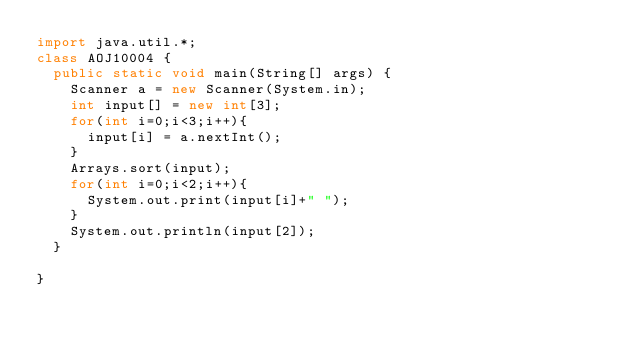<code> <loc_0><loc_0><loc_500><loc_500><_Java_>import java.util.*;
class AOJ10004 {
	public static void main(String[] args) {
		Scanner a = new Scanner(System.in);
		int input[] = new int[3];
		for(int i=0;i<3;i++){
			input[i] = a.nextInt();
		}
		Arrays.sort(input);
		for(int i=0;i<2;i++){
			System.out.print(input[i]+" ");
		}
		System.out.println(input[2]);
	}

}</code> 